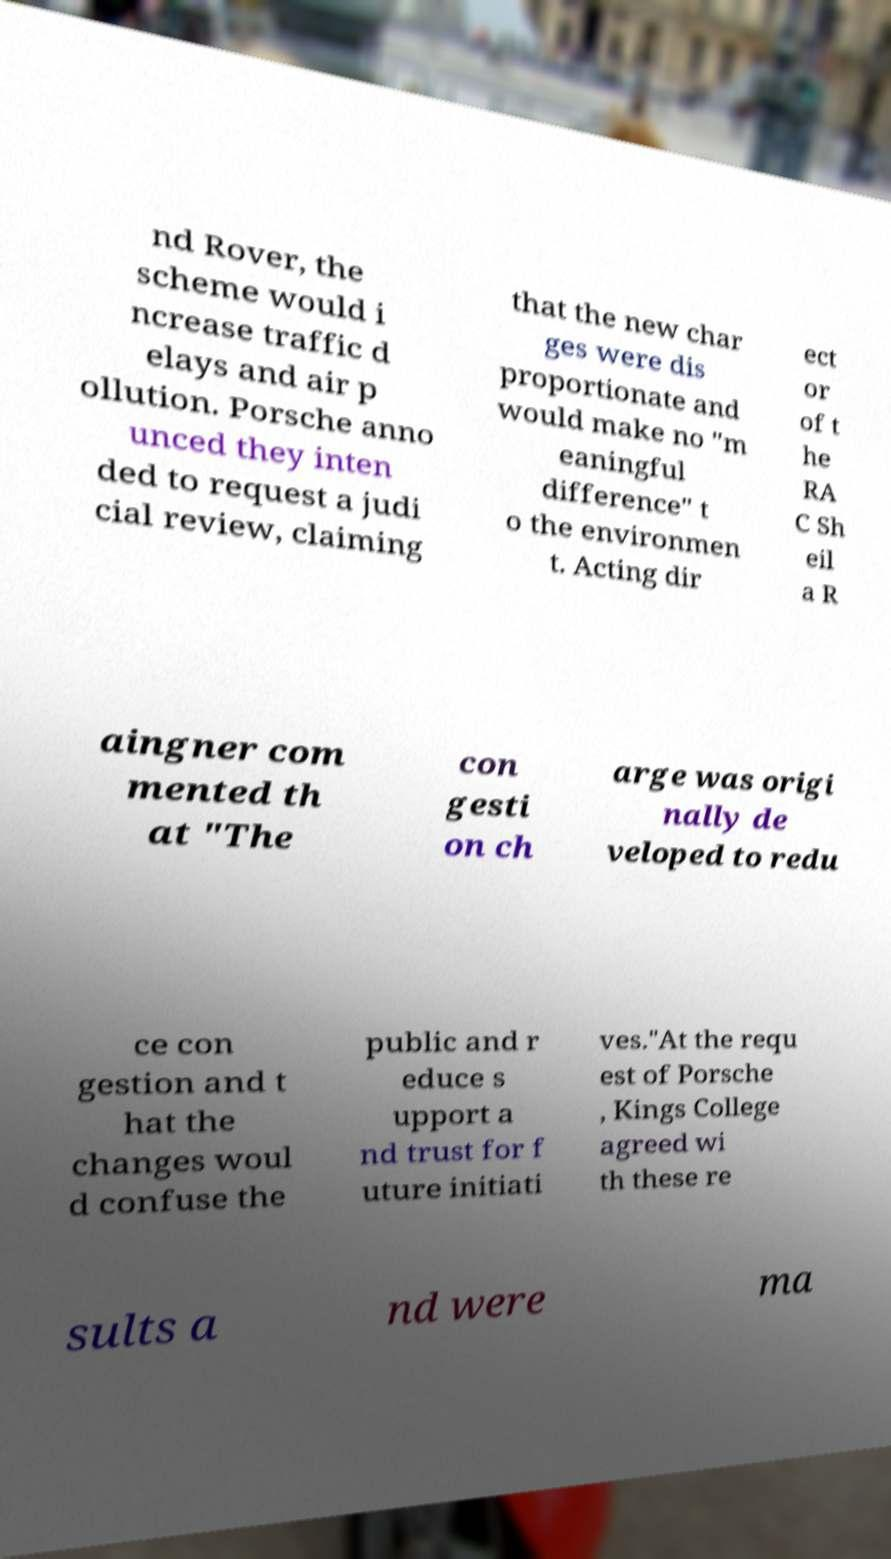For documentation purposes, I need the text within this image transcribed. Could you provide that? nd Rover, the scheme would i ncrease traffic d elays and air p ollution. Porsche anno unced they inten ded to request a judi cial review, claiming that the new char ges were dis proportionate and would make no "m eaningful difference" t o the environmen t. Acting dir ect or of t he RA C Sh eil a R aingner com mented th at "The con gesti on ch arge was origi nally de veloped to redu ce con gestion and t hat the changes woul d confuse the public and r educe s upport a nd trust for f uture initiati ves."At the requ est of Porsche , Kings College agreed wi th these re sults a nd were ma 